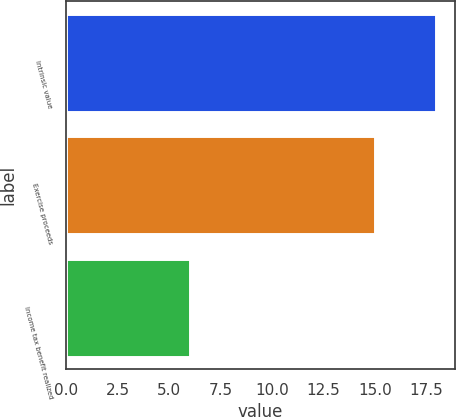<chart> <loc_0><loc_0><loc_500><loc_500><bar_chart><fcel>Intrinsic value<fcel>Exercise proceeds<fcel>Income tax benefit realized<nl><fcel>18<fcel>15<fcel>6<nl></chart> 